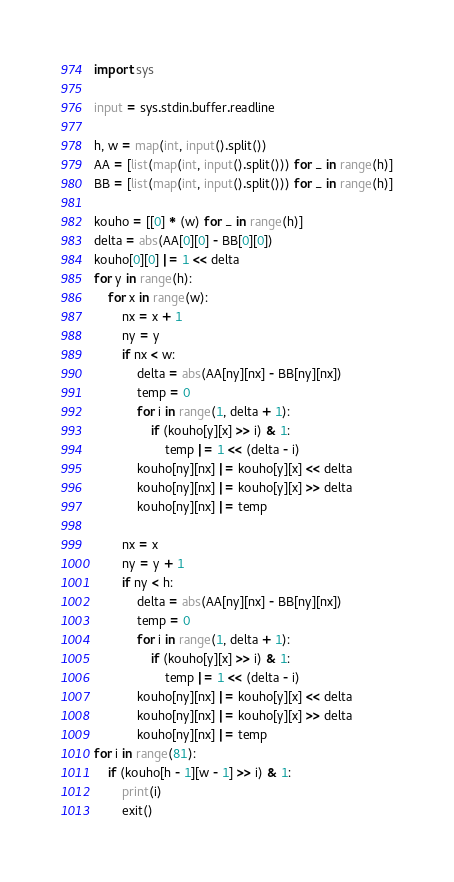<code> <loc_0><loc_0><loc_500><loc_500><_Python_>import sys

input = sys.stdin.buffer.readline

h, w = map(int, input().split())
AA = [list(map(int, input().split())) for _ in range(h)]
BB = [list(map(int, input().split())) for _ in range(h)]

kouho = [[0] * (w) for _ in range(h)]
delta = abs(AA[0][0] - BB[0][0])
kouho[0][0] |= 1 << delta
for y in range(h):
    for x in range(w):
        nx = x + 1
        ny = y
        if nx < w:
            delta = abs(AA[ny][nx] - BB[ny][nx])
            temp = 0
            for i in range(1, delta + 1):
                if (kouho[y][x] >> i) & 1:
                    temp |= 1 << (delta - i)
            kouho[ny][nx] |= kouho[y][x] << delta
            kouho[ny][nx] |= kouho[y][x] >> delta
            kouho[ny][nx] |= temp

        nx = x
        ny = y + 1
        if ny < h:
            delta = abs(AA[ny][nx] - BB[ny][nx])
            temp = 0
            for i in range(1, delta + 1):
                if (kouho[y][x] >> i) & 1:
                    temp |= 1 << (delta - i)
            kouho[ny][nx] |= kouho[y][x] << delta
            kouho[ny][nx] |= kouho[y][x] >> delta
            kouho[ny][nx] |= temp
for i in range(81):
    if (kouho[h - 1][w - 1] >> i) & 1:
        print(i)
        exit()
</code> 